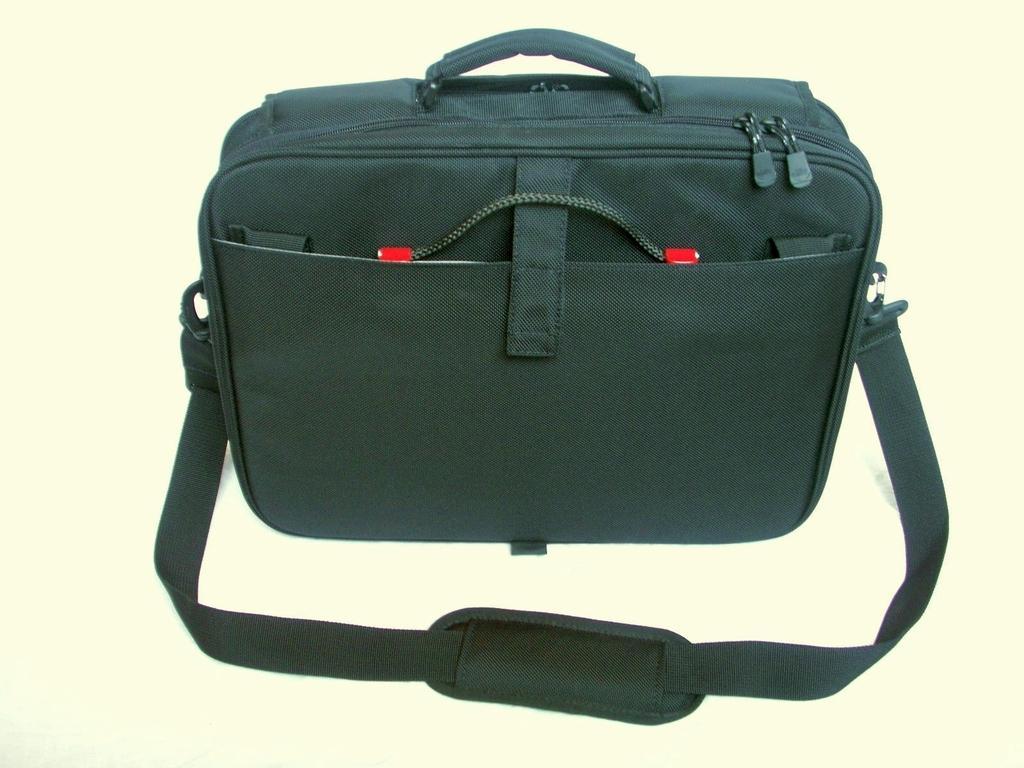Could you give a brief overview of what you see in this image? This is a picture of a black bag. 